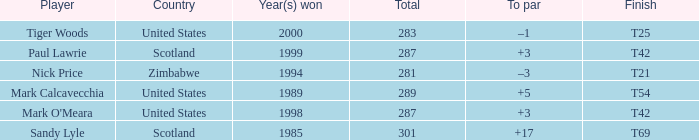What is the to par when the year(s) won is larger than 1999? –1. 